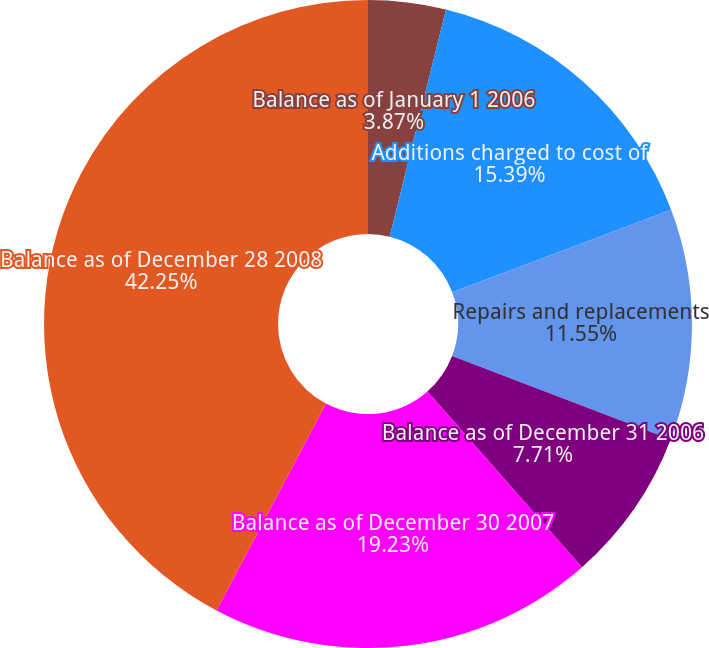<chart> <loc_0><loc_0><loc_500><loc_500><pie_chart><fcel>Balance as of January 1 2006<fcel>Additions charged to cost of<fcel>Repairs and replacements<fcel>Balance as of December 31 2006<fcel>Balance as of December 30 2007<fcel>Balance as of December 28 2008<nl><fcel>3.87%<fcel>15.39%<fcel>11.55%<fcel>7.71%<fcel>19.23%<fcel>42.26%<nl></chart> 